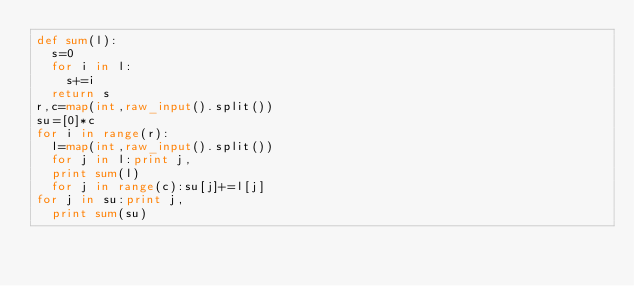Convert code to text. <code><loc_0><loc_0><loc_500><loc_500><_Python_>def sum(l):
	s=0
	for i in l:
		s+=i
	return s
r,c=map(int,raw_input().split())
su=[0]*c
for i in range(r):
	l=map(int,raw_input().split())
	for j in l:print j,
	print sum(l)
	for j in range(c):su[j]+=l[j]
for j in su:print j,
	print sum(su)</code> 